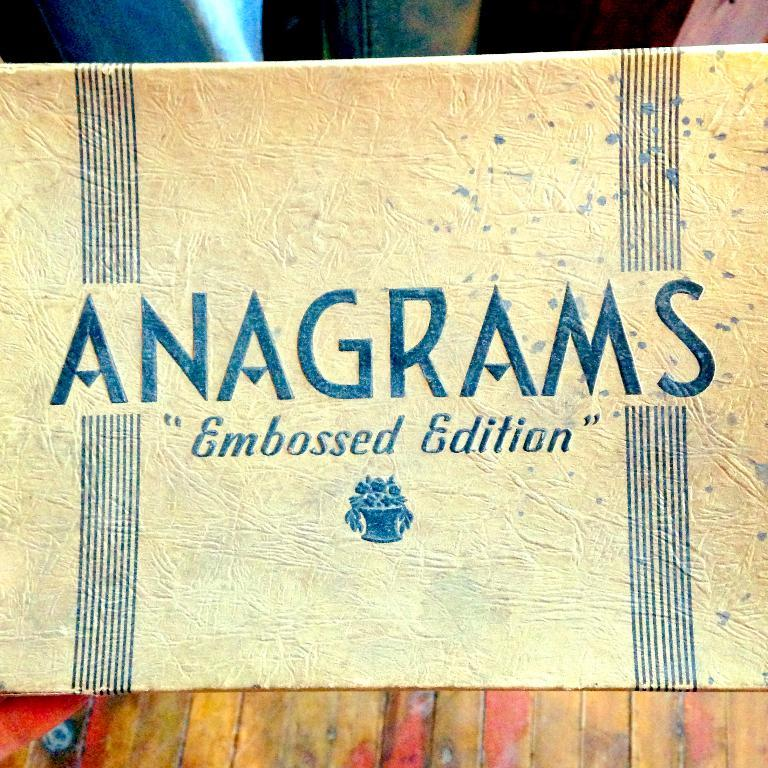<image>
Write a terse but informative summary of the picture. a close up of an Anagrams Embossed Edition card 